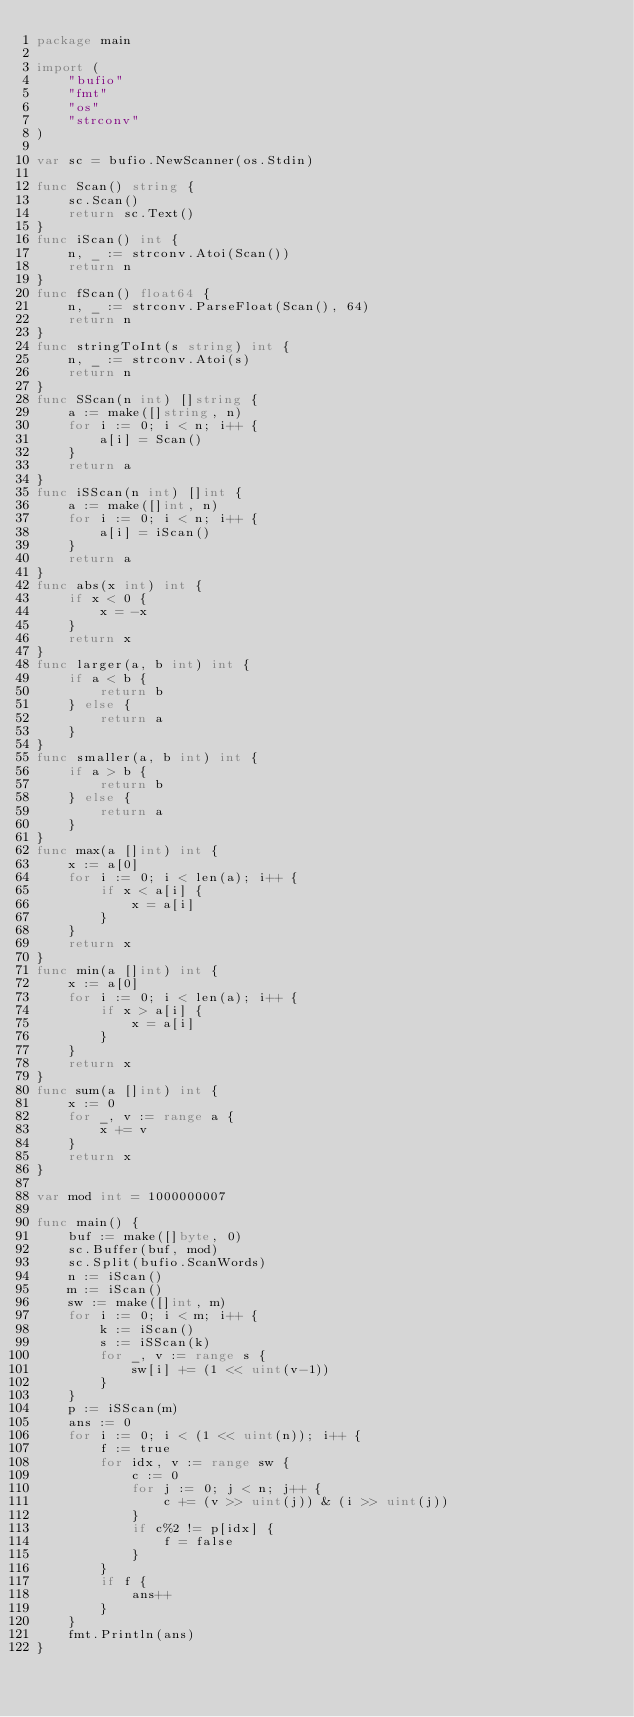<code> <loc_0><loc_0><loc_500><loc_500><_Go_>package main

import (
	"bufio"
	"fmt"
	"os"
	"strconv"
)

var sc = bufio.NewScanner(os.Stdin)

func Scan() string {
	sc.Scan()
	return sc.Text()
}
func iScan() int {
	n, _ := strconv.Atoi(Scan())
	return n
}
func fScan() float64 {
	n, _ := strconv.ParseFloat(Scan(), 64)
	return n
}
func stringToInt(s string) int {
	n, _ := strconv.Atoi(s)
	return n
}
func SScan(n int) []string {
	a := make([]string, n)
	for i := 0; i < n; i++ {
		a[i] = Scan()
	}
	return a
}
func iSScan(n int) []int {
	a := make([]int, n)
	for i := 0; i < n; i++ {
		a[i] = iScan()
	}
	return a
}
func abs(x int) int {
	if x < 0 {
		x = -x
	}
	return x
}
func larger(a, b int) int {
	if a < b {
		return b
	} else {
		return a
	}
}
func smaller(a, b int) int {
	if a > b {
		return b
	} else {
		return a
	}
}
func max(a []int) int {
	x := a[0]
	for i := 0; i < len(a); i++ {
		if x < a[i] {
			x = a[i]
		}
	}
	return x
}
func min(a []int) int {
	x := a[0]
	for i := 0; i < len(a); i++ {
		if x > a[i] {
			x = a[i]
		}
	}
	return x
}
func sum(a []int) int {
	x := 0
	for _, v := range a {
		x += v
	}
	return x
}

var mod int = 1000000007

func main() {
	buf := make([]byte, 0)
	sc.Buffer(buf, mod)
	sc.Split(bufio.ScanWords)
	n := iScan()
	m := iScan()
	sw := make([]int, m)
	for i := 0; i < m; i++ {
		k := iScan()
		s := iSScan(k)
		for _, v := range s {
			sw[i] += (1 << uint(v-1))
		}
	}
	p := iSScan(m)
	ans := 0
	for i := 0; i < (1 << uint(n)); i++ {
		f := true
		for idx, v := range sw {
			c := 0
			for j := 0; j < n; j++ {
				c += (v >> uint(j)) & (i >> uint(j))
			}
			if c%2 != p[idx] {
				f = false
			}
		}
		if f {
			ans++
		}
	}
	fmt.Println(ans)
}
</code> 